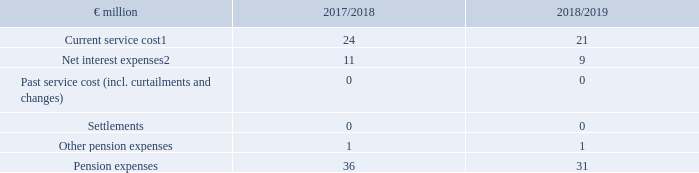The pension expenses of the direct and indirect company pension plan commitments can be broken down as follows:
1 Netted against employees’ contributions.
2 Included therein: Interest effect from the adjustment of the asset ceiling.
The entire loss to be recognised outside of profit or loss in the other comprehensive income amounts to €90 million in financial year 2018/19. This figure is comprised of the effect from the change in actuarial parameters in the amount of €+247 million and the experience-based adjustments of €+4 million. It was offset by income from plan assets of €103 million and a gain of €58 million resulting from the change in the effect of the asset ceiling in the Netherlands.
In addition to expenses from defined benefit commitments, expenses for payments to external pension providers relating to defined contribution pension commitments of €82 million in financial year 2018/19 (2017/18: €82 million) were recorded. These figures also include payments to statutory pension insurance.
The provisions for obligations similar to pensions essentially comprise commitments from employment anniversary allowances, death benefits and partial retirement plans. Provisions amounting to €34 million (30/9/2018: €41 million) were allocated for these commitments. The commitments are valued on the basis of actuarial expert opinions. The valuation parameters used for this purpose are generally determined in the same way as for the company pension plan.
What was the current service cost netted against? Employees’ contributions. What was included therein within the net interest expenses? Interest effect from the adjustment of the asset ceiling. For which years were the pension expenses of the direct and indirect company pension plan commitments recorded in? 2018, 2019. In which year were the pension expenses larger? 36>31
Answer: 2018. What was the change in pension expenses in FY2019 from FY2018?
Answer scale should be: million. 31-36
Answer: -5. What was the percentage change in pension expenses in FY2019 from FY2018?
Answer scale should be: percent. (31-36)/36
Answer: -13.89. 